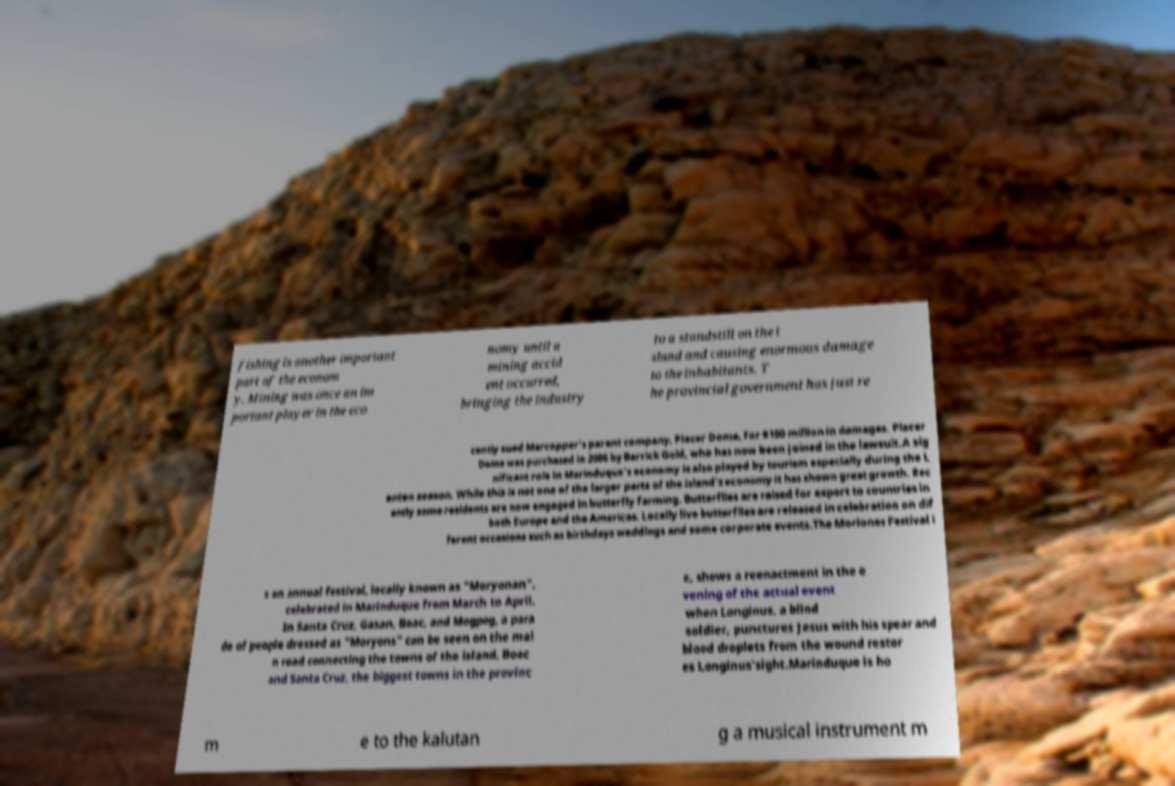Could you assist in decoding the text presented in this image and type it out clearly? fishing is another important part of the econom y. Mining was once an im portant player in the eco nomy until a mining accid ent occurred, bringing the industry to a standstill on the i sland and causing enormous damage to the inhabitants. T he provincial government has just re cently sued Marcopper's parent company, Placer Dome, for $100 million in damages. Placer Dome was purchased in 2006 by Barrick Gold, who has now been joined in the lawsuit.A sig nificant role in Marinduque's economy is also played by tourism especially during the L enten season. While this is not one of the larger parts of the island's economy it has shown great growth. Rec ently some residents are now engaged in butterfly farming. Butterflies are raised for export to countries in both Europe and the Americas. Locally live butterflies are released in celebration on dif ferent occasions such as birthdays weddings and some corporate events.The Moriones Festival i s an annual festival, locally known as "Moryonan", celebrated in Marinduque from March to April. In Santa Cruz, Gasan, Boac, and Mogpog, a para de of people dressed as "Moryons" can be seen on the mai n road connecting the towns of the island. Boac and Santa Cruz, the biggest towns in the provinc e, shows a reenactment in the e vening of the actual event when Longinus, a blind soldier, punctures Jesus with his spear and blood droplets from the wound restor es Longinus'sight.Marinduque is ho m e to the kalutan g a musical instrument m 